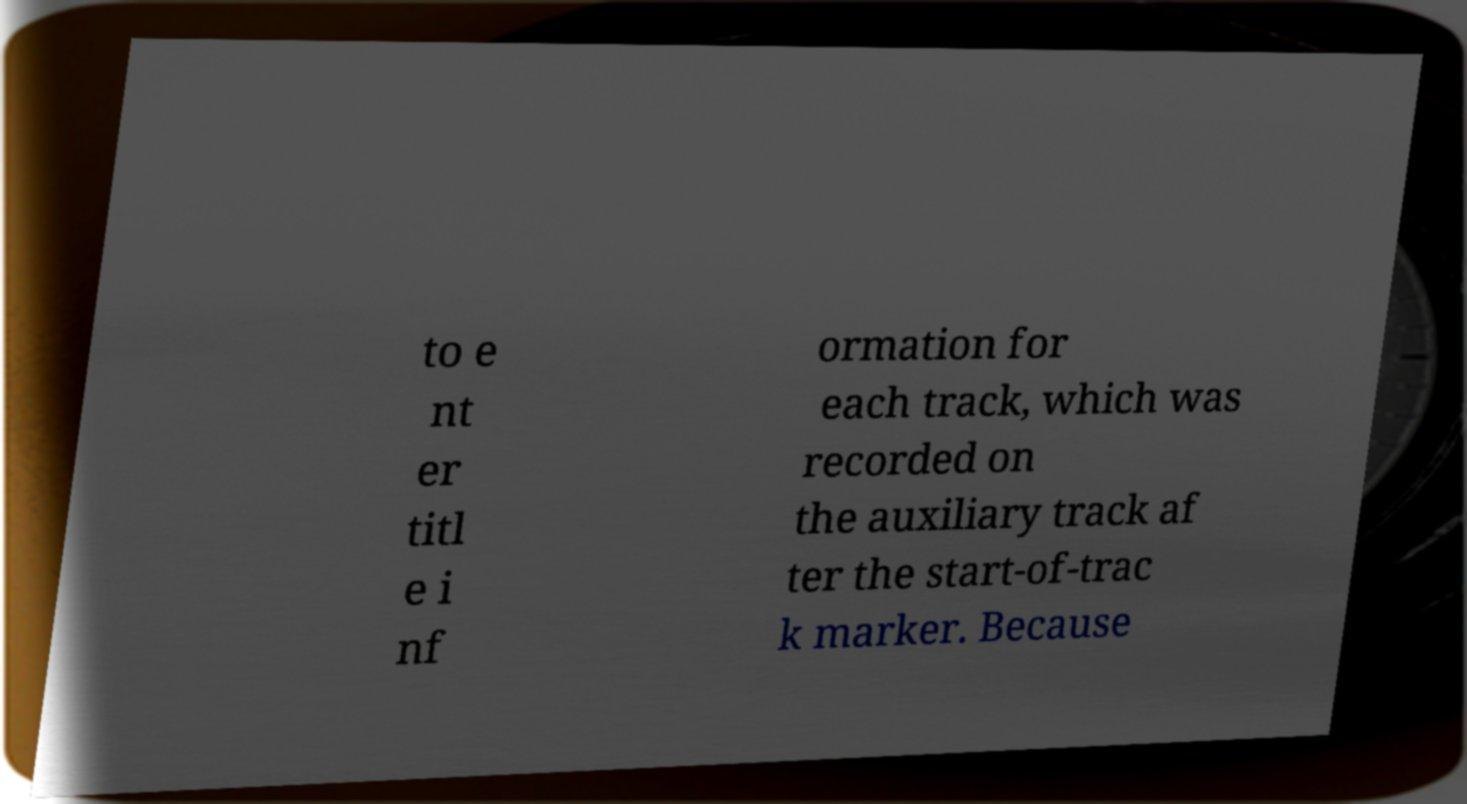Could you extract and type out the text from this image? to e nt er titl e i nf ormation for each track, which was recorded on the auxiliary track af ter the start-of-trac k marker. Because 